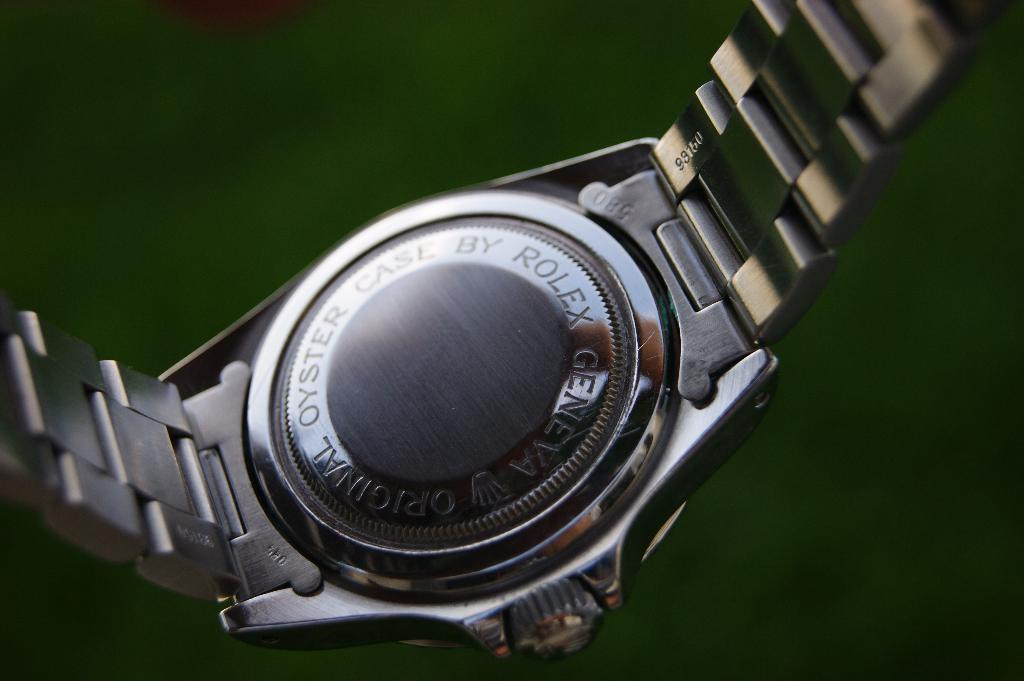<image>
Provide a brief description of the given image. the back of a rolex geneva original oyster case watch 